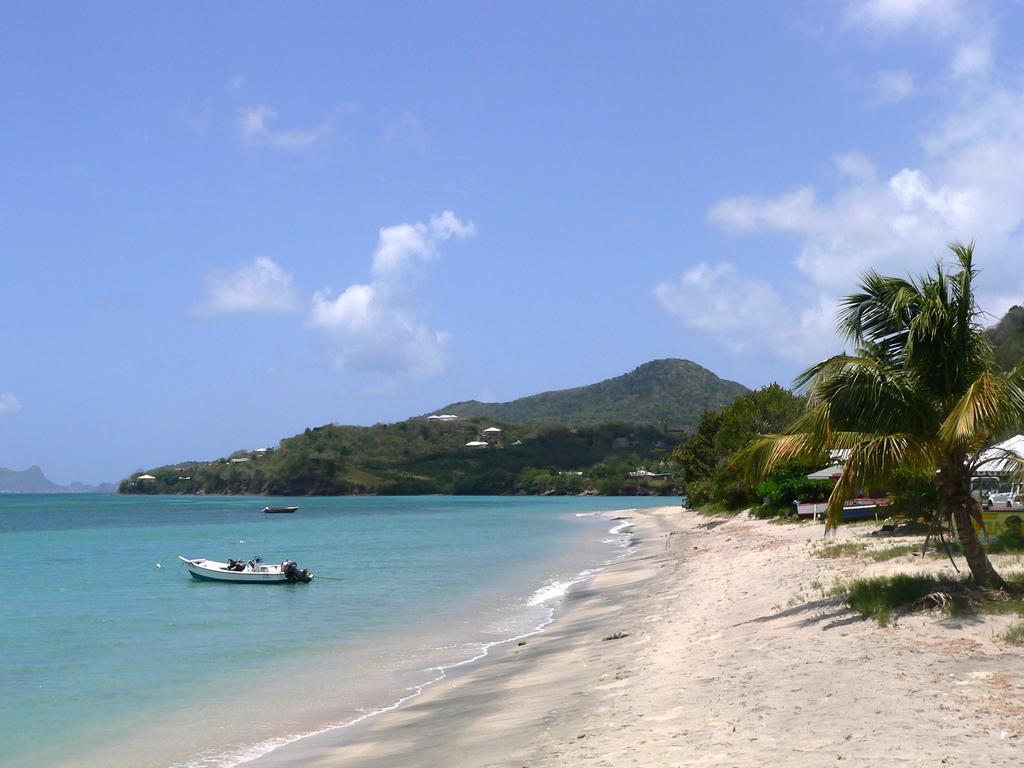Describe this image in one or two sentences. In this picture there are trees on the right side of the image and there is a boat on the water, on the left side of the image, there are mountains in the center of the image, it seems to be the bank of a beach. 